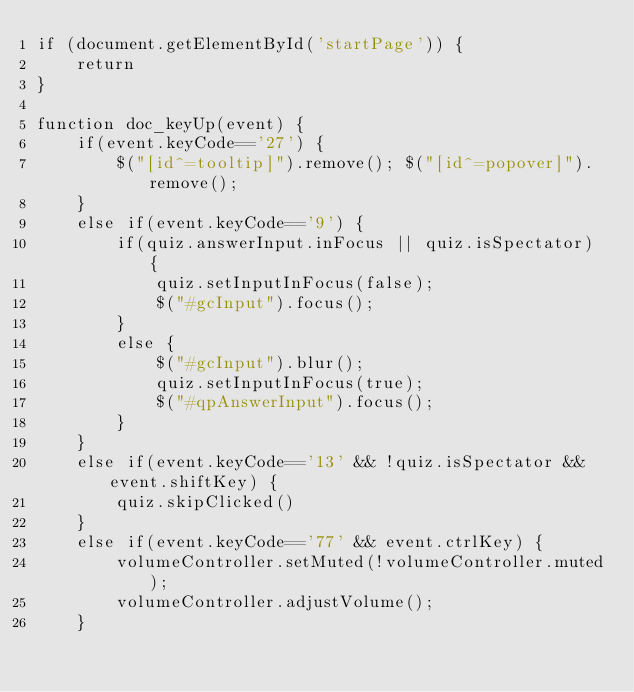<code> <loc_0><loc_0><loc_500><loc_500><_JavaScript_>if (document.getElementById('startPage')) {
    return
}

function doc_keyUp(event) {
	if(event.keyCode=='27') {
		$("[id^=tooltip]").remove(); $("[id^=popover]").remove();
	}
	else if(event.keyCode=='9') {
		if(quiz.answerInput.inFocus || quiz.isSpectator) {
			quiz.setInputInFocus(false);
			$("#gcInput").focus();
		}
		else {
			$("#gcInput").blur();
			quiz.setInputInFocus(true);
			$("#qpAnswerInput").focus();
		}
	}
	else if(event.keyCode=='13' && !quiz.isSpectator && event.shiftKey) {
		quiz.skipClicked()
	}
	else if(event.keyCode=='77' && event.ctrlKey) {
		volumeController.setMuted(!volumeController.muted);
		volumeController.adjustVolume();
	}</code> 